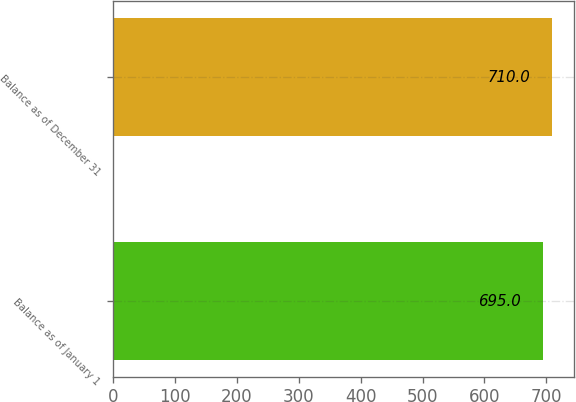Convert chart to OTSL. <chart><loc_0><loc_0><loc_500><loc_500><bar_chart><fcel>Balance as of January 1<fcel>Balance as of December 31<nl><fcel>695<fcel>710<nl></chart> 